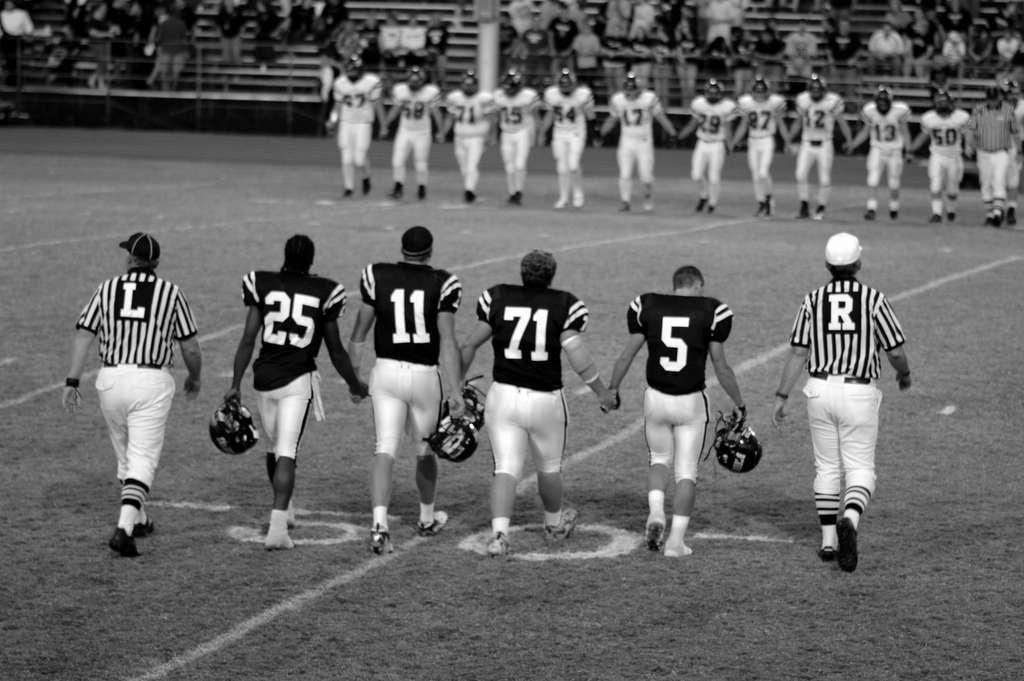<image>
Provide a brief description of the given image. The players walk inbetween two refs with the letters L and R on the backs of their tops. 